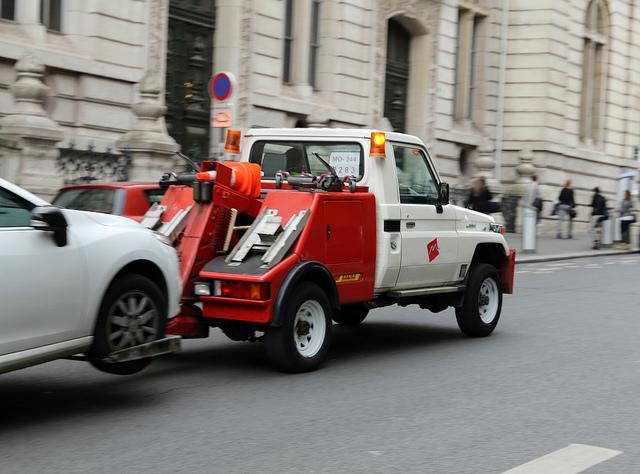How is the car on the back being propelled? Please explain your reasoning. towed. The car is lifted up and connected to a truck with a crane. 